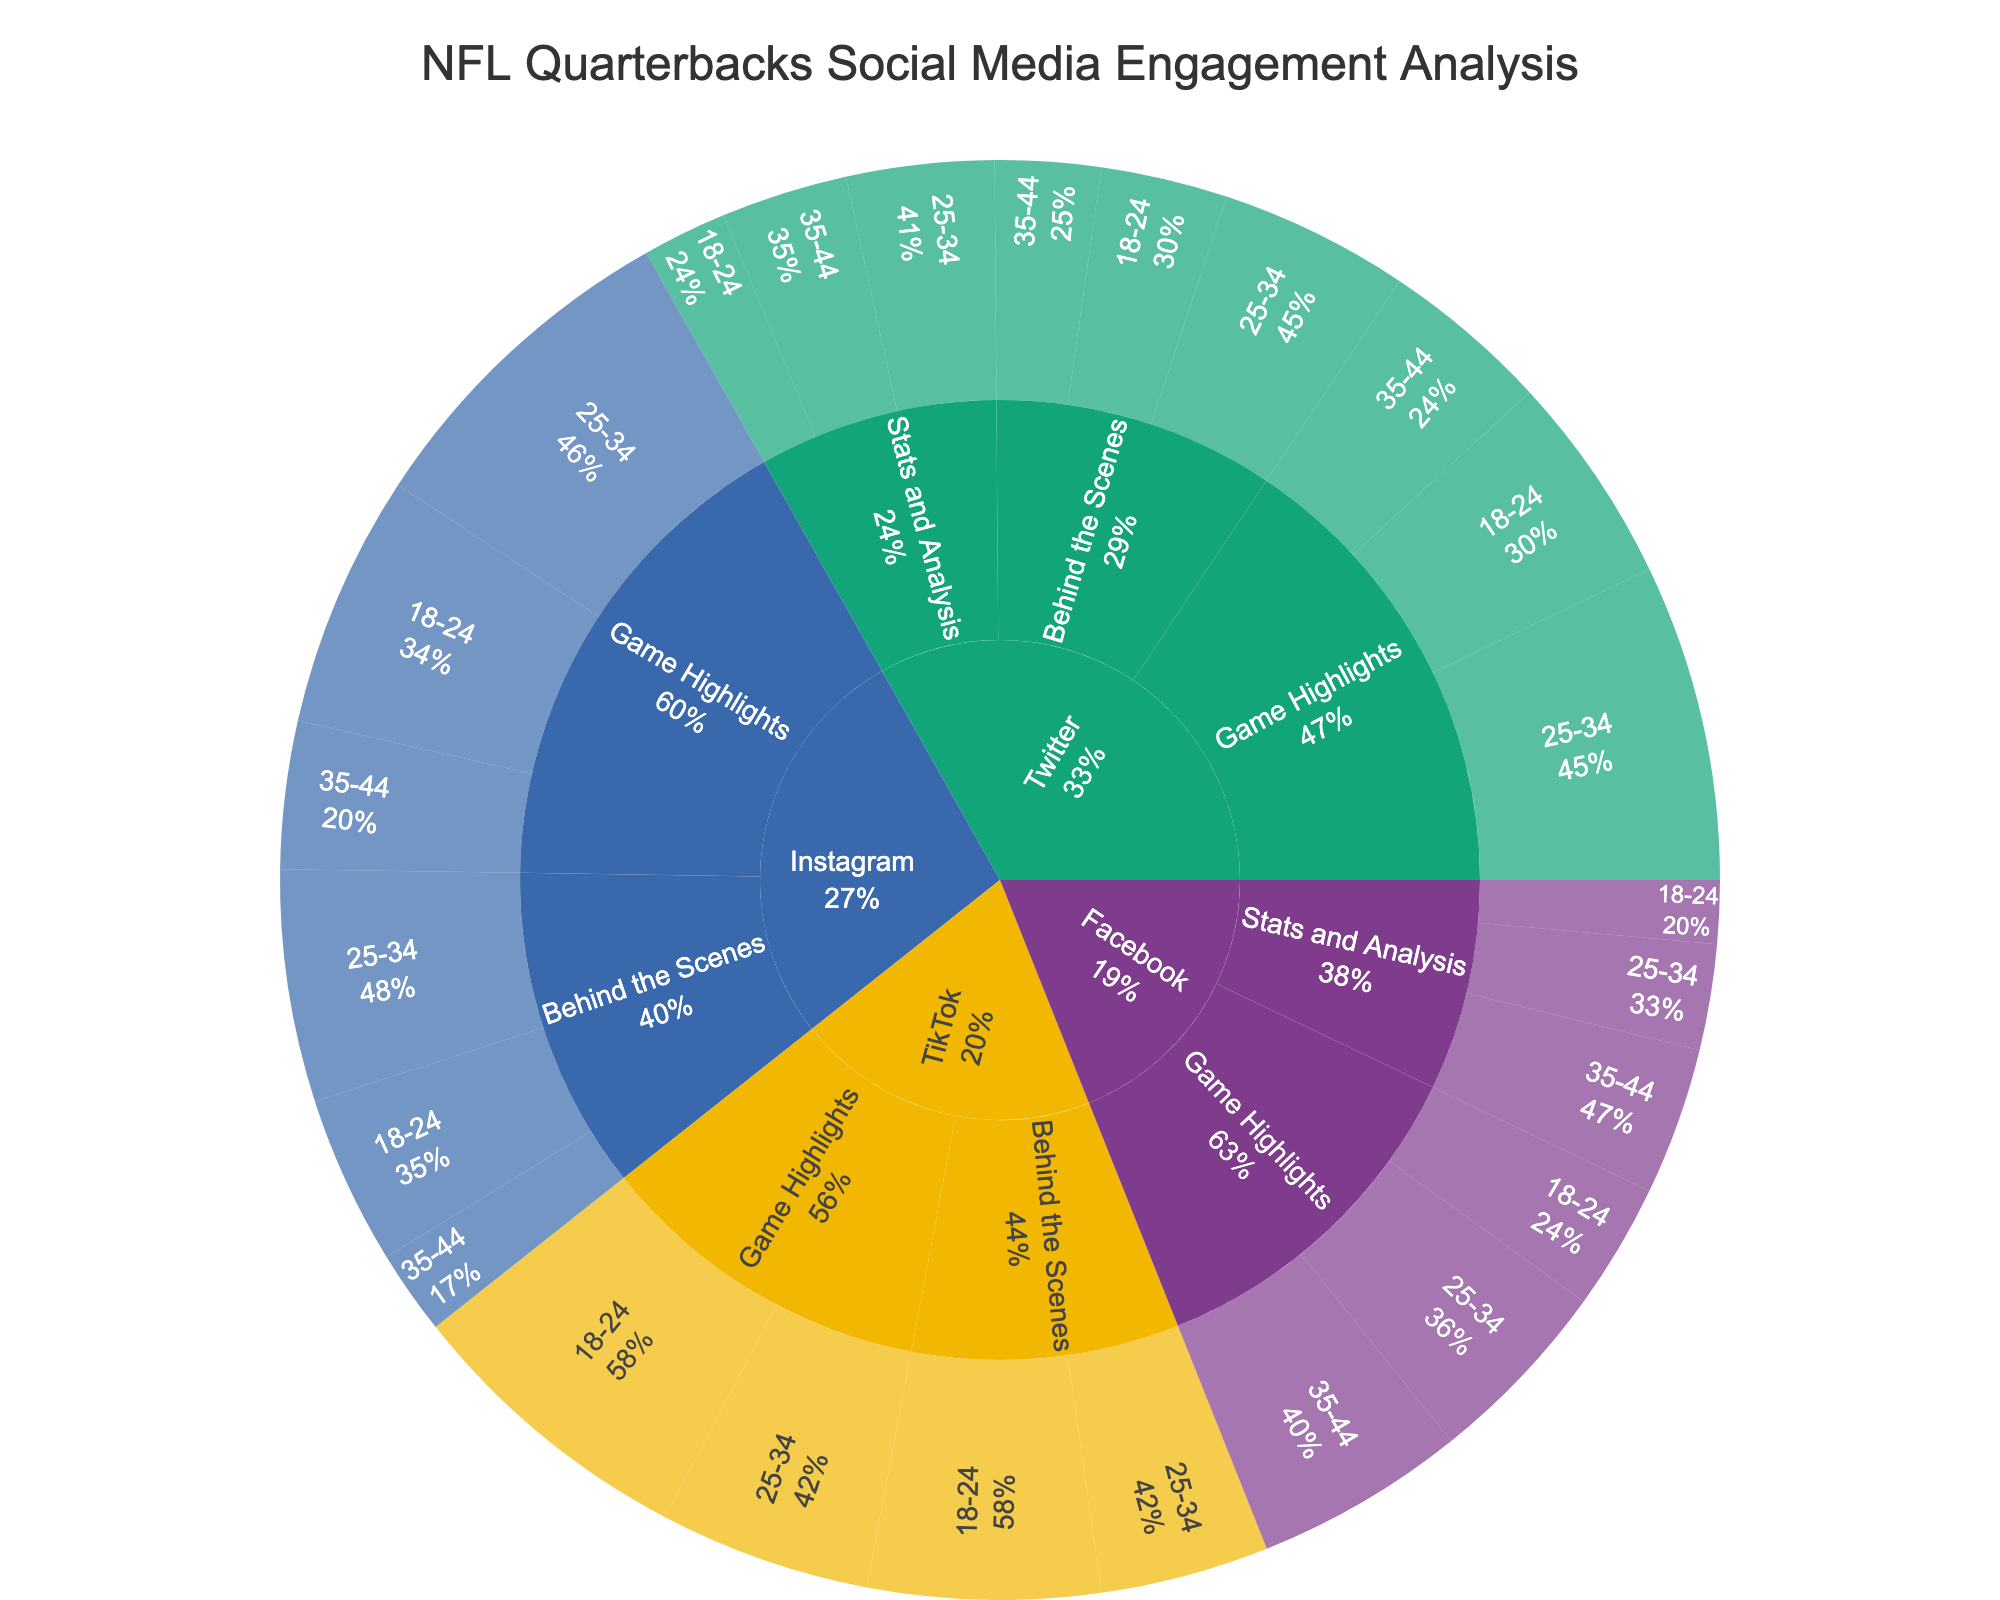What's the total engagement for 'Game Highlights' on Instagram? To find the total engagement for 'Game Highlights' on Instagram, locate the sum of engagements by the age demographics 18-24, 25-34, and 35-44 on Instagram for 'Game Highlights'. The values are 600,000 + 800,000 + 350,000 = 1,750,000.
Answer: 1,750,000 Which platform has the highest engagement for 'Behind the Scenes' content for the 18-24 demographic? Compare the engagement values of 'Behind the Scenes' content for the 18-24 demographic across all platforms. The values are Twitter (300,000), Instagram (400,000), and TikTok (550,000). TikTok has the highest engagement.
Answer: TikTok What's the engagement difference between 'Stats and Analysis' and 'Game Highlights' on Twitter for the 25-34 demographic? Subtract the engagement of 'Stats and Analysis' (350,000) from 'Game Highlights' (750,000) on Twitter for the 25-34 demographic. The difference is 750,000 - 350,000 = 400,000.
Answer: 400,000 Which content type on TikTok has higher engagement for the 25-34 demographic, 'Game Highlights' or 'Behind the Scenes'? Compare the engagement values on TikTok for 'Game Highlights' (500,000) and 'Behind the Scenes' (400,000) for the 25-34 demographic. 'Game Highlights' has higher engagement.
Answer: Game Highlights How much higher is the engagement for 'Game Highlights' on Instagram for the 25-34 demographic compared to the 18-24 demographic? Subtract the engagement of 'Game Highlights' for 18-24 demographic (600,000) from the 25-34 demographic (800,000) on Instagram. The difference is 800,000 - 600,000 = 200,000.
Answer: 200,000 What's the average engagement for 'Behind the Scenes' content across all platforms for the 25-34 demographic? To find the average, sum the engagements of 'Behind the Scenes' content for the 25-34 demographic on all platforms (Twitter: 450,000, Instagram: 550,000, TikTok: 400,000) and divide by the number of platforms, 3. The total sum is 450,000 + 550,000 + 400,000 = 1,400,000. The average is 1,400,000 / 3 = 466,667.
Answer: 466,667 Which demographic has the lowest engagement for 'Stats and Analysis' on Facebook? Compare the engagement values for 'Stats and Analysis' across the demographics on Facebook: 18-24 (150,000), 25-34 (250,000), and 35-44 (350,000). The 18-24 demographic has the lowest engagement.
Answer: 18-24 What's the total engagement for all content types on Twitter? Sum up all engagements on Twitter: 
(500,000 + 750,000 + 400,000 + 300,000 + 450,000 + 250,000 + 200,000 + 350,000 + 300,000). The total is 500,000 + 750,000 + 400,000 + 300,000 + 450,000 + 250,000 + 200,000 + 350,000 + 300,000 = 3,500,000.
Answer: 3,500,000 